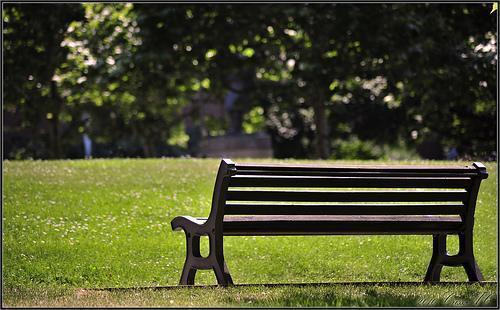How many benches are there?
Give a very brief answer. 1. 